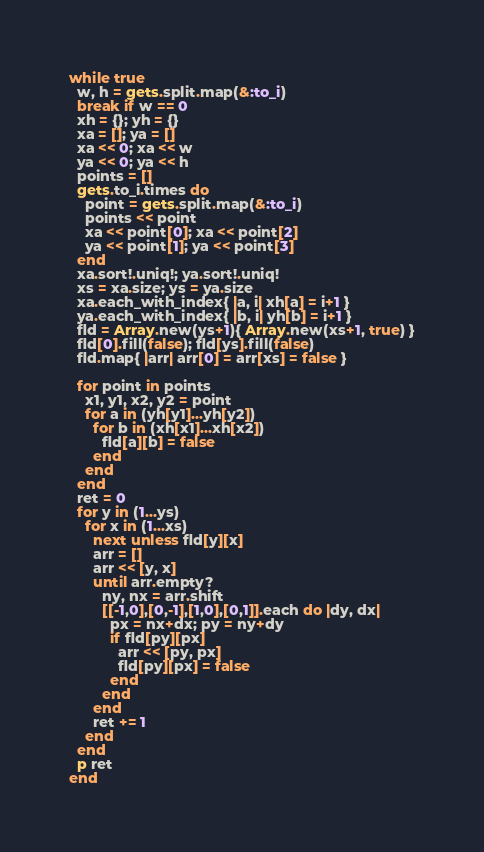<code> <loc_0><loc_0><loc_500><loc_500><_Ruby_>while true
  w, h = gets.split.map(&:to_i)
  break if w == 0
  xh = {}; yh = {}
  xa = []; ya = []
  xa << 0; xa << w
  ya << 0; ya << h
  points = []
  gets.to_i.times do
    point = gets.split.map(&:to_i)
    points << point
    xa << point[0]; xa << point[2]
    ya << point[1]; ya << point[3]
  end
  xa.sort!.uniq!; ya.sort!.uniq!
  xs = xa.size; ys = ya.size
  xa.each_with_index{ |a, i| xh[a] = i+1 }
  ya.each_with_index{ |b, i| yh[b] = i+1 }
  fld = Array.new(ys+1){ Array.new(xs+1, true) }
  fld[0].fill(false); fld[ys].fill(false)
  fld.map{ |arr| arr[0] = arr[xs] = false }
 
  for point in points
    x1, y1, x2, y2 = point
    for a in (yh[y1]...yh[y2])
      for b in (xh[x1]...xh[x2])
        fld[a][b] = false
      end
    end
  end
  ret = 0
  for y in (1...ys)
    for x in (1...xs)
      next unless fld[y][x]
      arr = []
      arr << [y, x]
      until arr.empty?
        ny, nx = arr.shift
        [[-1,0],[0,-1],[1,0],[0,1]].each do |dy, dx|
          px = nx+dx; py = ny+dy
          if fld[py][px]
            arr << [py, px] 
            fld[py][px] = false
          end
        end
      end
      ret += 1
    end
  end
  p ret
end</code> 